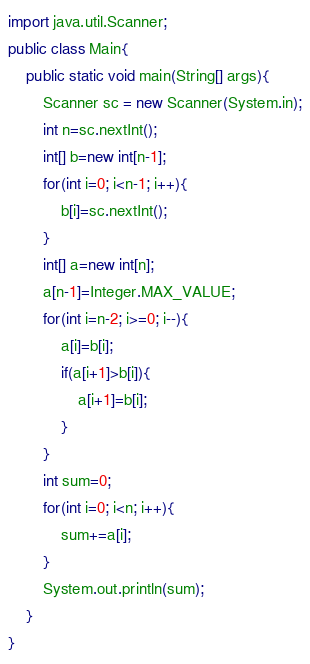<code> <loc_0><loc_0><loc_500><loc_500><_Java_>import java.util.Scanner;
public class Main{
	public static void main(String[] args){
		Scanner sc = new Scanner(System.in);
		int n=sc.nextInt();
		int[] b=new int[n-1];
		for(int i=0; i<n-1; i++){
			b[i]=sc.nextInt();
		}
		int[] a=new int[n];
		a[n-1]=Integer.MAX_VALUE;
		for(int i=n-2; i>=0; i--){
			a[i]=b[i];
			if(a[i+1]>b[i]){
				a[i+1]=b[i];
			}
		}
		int sum=0;
		for(int i=0; i<n; i++){
			sum+=a[i];
		}
		System.out.println(sum);
	}
}
</code> 